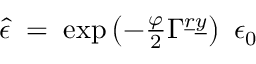Convert formula to latex. <formula><loc_0><loc_0><loc_500><loc_500>\hat { \epsilon } \, = \, \exp \left ( - \frac { \varphi } { 2 } \Gamma ^ { \underline { r } \underline { y } } \right ) \ \epsilon _ { 0 }</formula> 